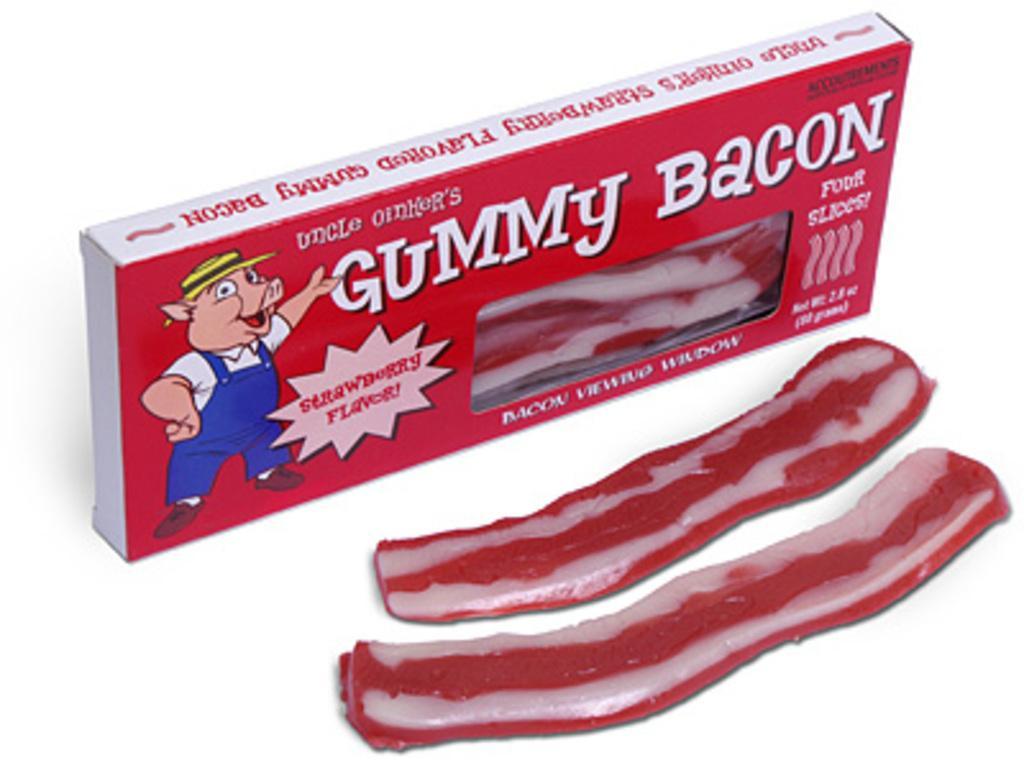In one or two sentences, can you explain what this image depicts? In this image there is a box and chewing gums are on the surface. On the box there is some text and a cartoon image are on it. 